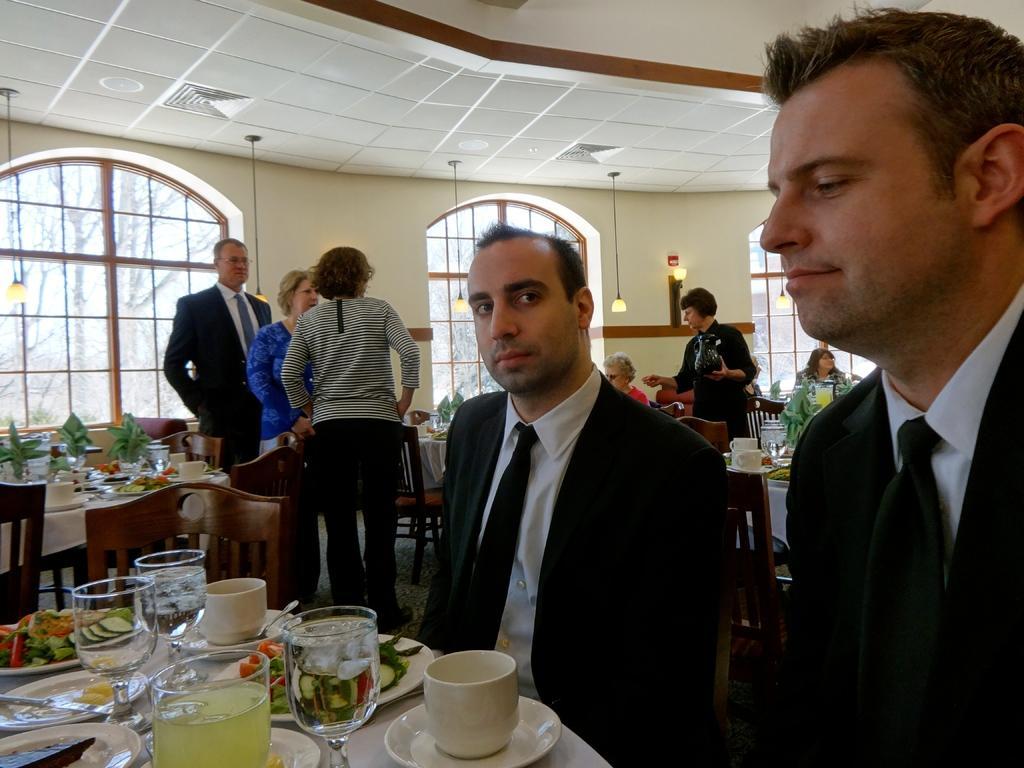Describe this image in one or two sentences. In the picture we can see some persons standing and some are sitting on chairs and there are some plates, glasses and some other food items on table and in the background there are some windows, wall through which we can see some trees. 